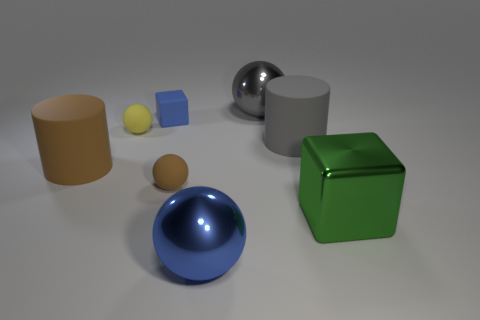Add 1 large green metallic blocks. How many objects exist? 9 Subtract all blue balls. How many balls are left? 3 Subtract 1 cylinders. How many cylinders are left? 1 Subtract all green blocks. How many blocks are left? 1 Add 4 big gray spheres. How many big gray spheres exist? 5 Subtract 0 blue cylinders. How many objects are left? 8 Subtract all blocks. How many objects are left? 6 Subtract all purple cylinders. Subtract all gray blocks. How many cylinders are left? 2 Subtract all red cylinders. How many blue cubes are left? 1 Subtract all big brown matte objects. Subtract all rubber cubes. How many objects are left? 6 